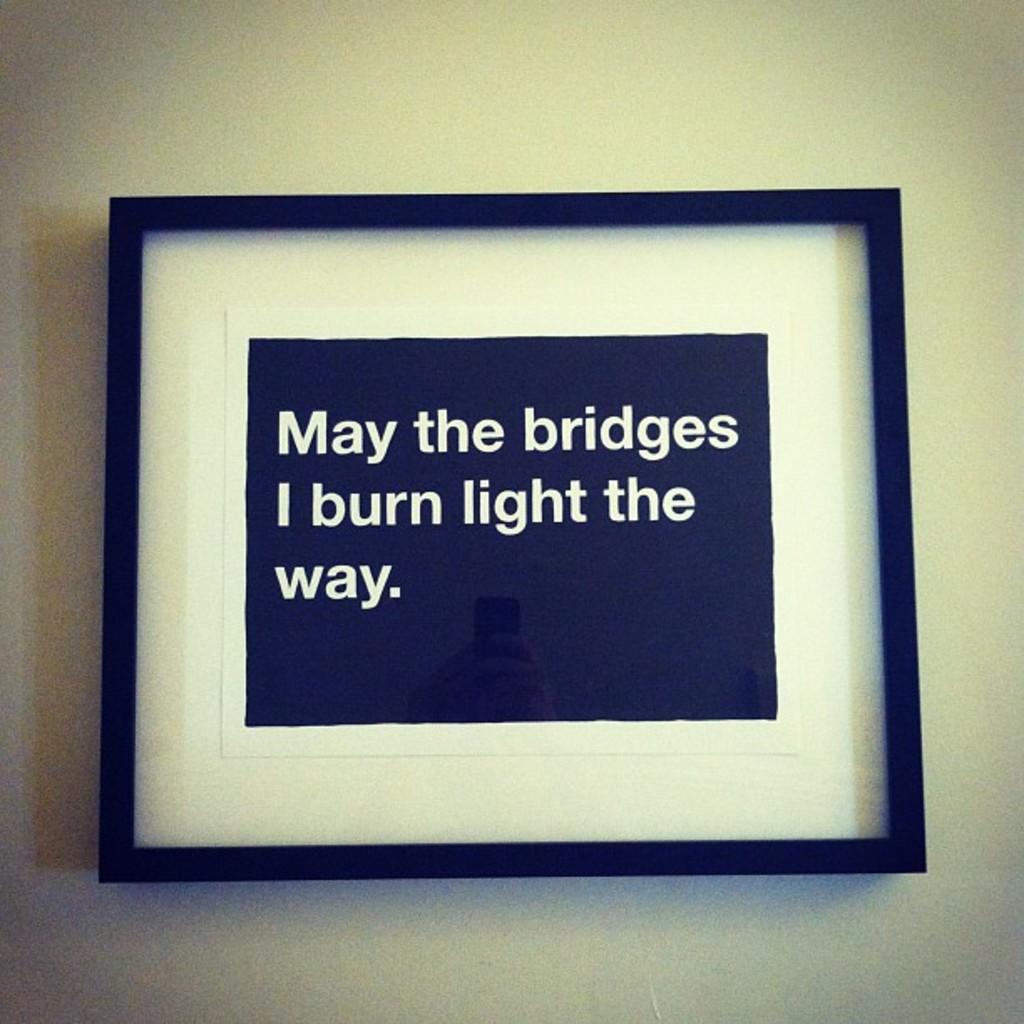May the bridges i burn light the what?
Give a very brief answer. Way. 